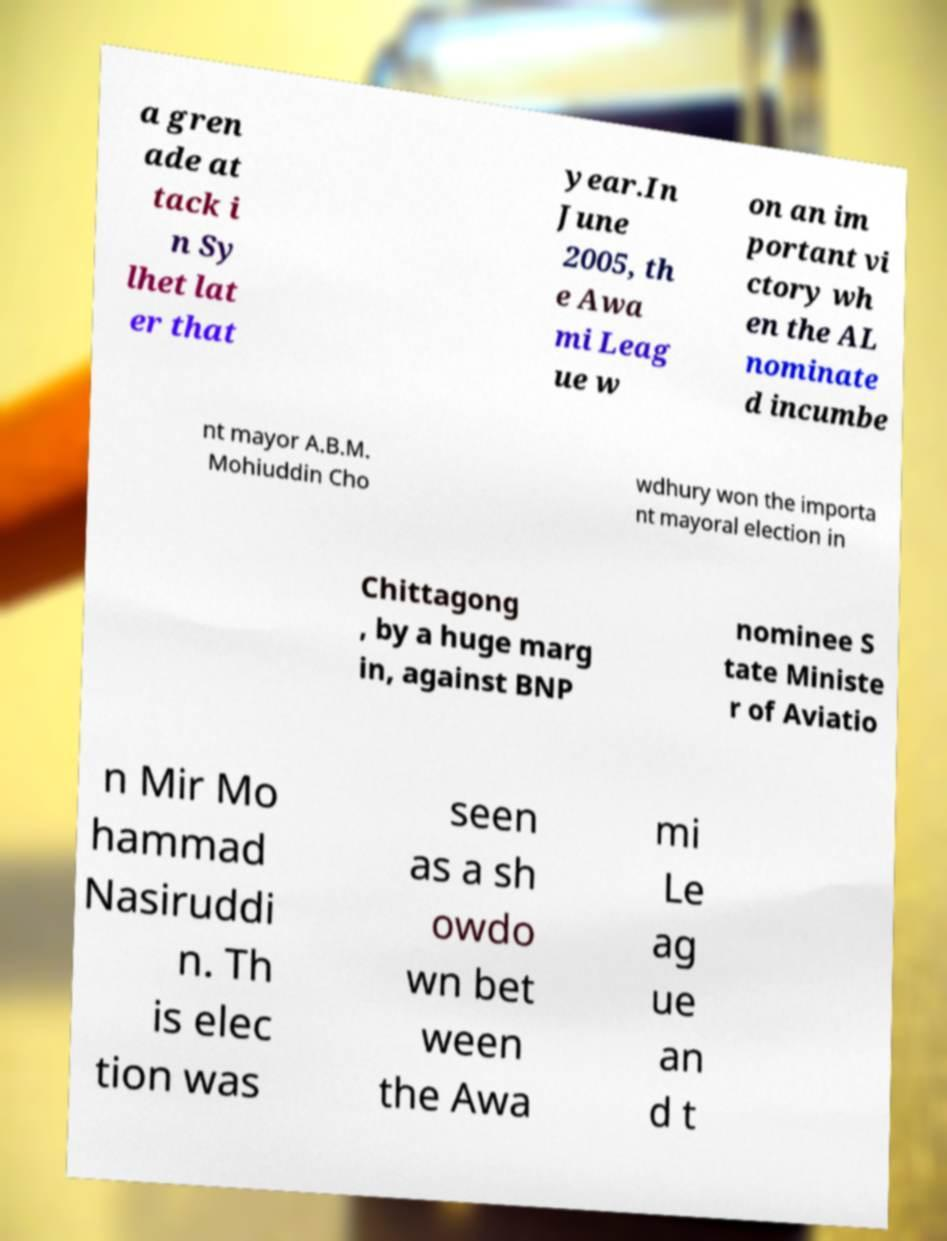Can you read and provide the text displayed in the image?This photo seems to have some interesting text. Can you extract and type it out for me? a gren ade at tack i n Sy lhet lat er that year.In June 2005, th e Awa mi Leag ue w on an im portant vi ctory wh en the AL nominate d incumbe nt mayor A.B.M. Mohiuddin Cho wdhury won the importa nt mayoral election in Chittagong , by a huge marg in, against BNP nominee S tate Ministe r of Aviatio n Mir Mo hammad Nasiruddi n. Th is elec tion was seen as a sh owdo wn bet ween the Awa mi Le ag ue an d t 